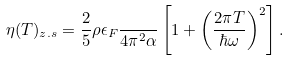Convert formula to latex. <formula><loc_0><loc_0><loc_500><loc_500>\eta ( T ) _ { z . s } = \frac { 2 } { 5 } \rho \epsilon _ { F } \frac { } { 4 \pi ^ { 2 } \alpha } \left [ 1 + \left ( \frac { 2 \pi T } { \hbar { \omega } } \right ) ^ { 2 } \right ] .</formula> 